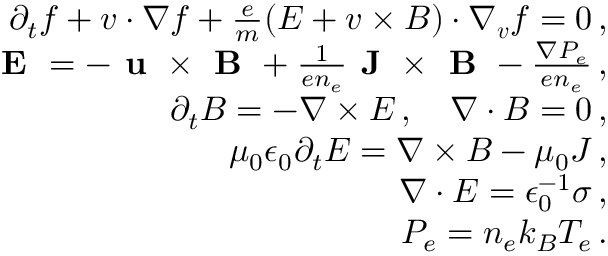Convert formula to latex. <formula><loc_0><loc_0><loc_500><loc_500>\begin{array} { r l r } & { \partial _ { t } f + v \cdot \nabla f + \frac { e } { m } ( { \boldsymbol E } + v \times { \boldsymbol B } ) \cdot \nabla _ { v } f = 0 \, , } \\ & { E = - u \times B + \frac { 1 } { e n _ { e } } J \times B - \frac { \nabla P _ { e } } { e n _ { e } } \, , } \\ & { \partial _ { t } { \boldsymbol B } = - \nabla \times { \boldsymbol E } \, , \quad \nabla \cdot { \boldsymbol B } = 0 \, , } \\ & { \mu _ { 0 } \epsilon _ { 0 } \partial _ { t } { \boldsymbol E } = \nabla \times { \boldsymbol B } - \mu _ { 0 } { \boldsymbol J } \, , } \\ & { \nabla \cdot { \boldsymbol E } = \epsilon _ { 0 } ^ { - 1 } \sigma \, , } \\ & { P _ { e } = n _ { e } k _ { B } T _ { e } \, . } \end{array}</formula> 